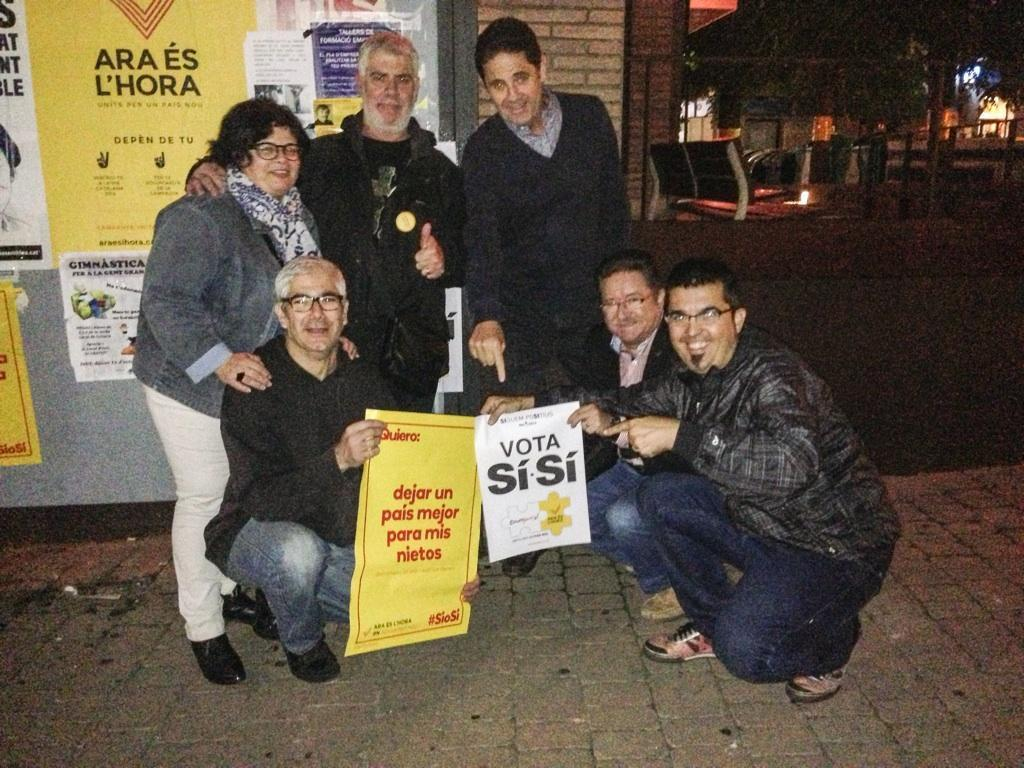What are the persons in the center of the image holding? The persons in the center of the image are holding papers. What can be seen in the background of the image? In the background of the image, there are posts, at least one building, a chair, trees, and lights. How many elements can be identified in the background of the image? There are five elements identifiable in the background of the image: posts, a building, a chair, trees, and lights. What type of kite is being flown by the person in the image? There is no kite present in the image; the persons are holding papers. 